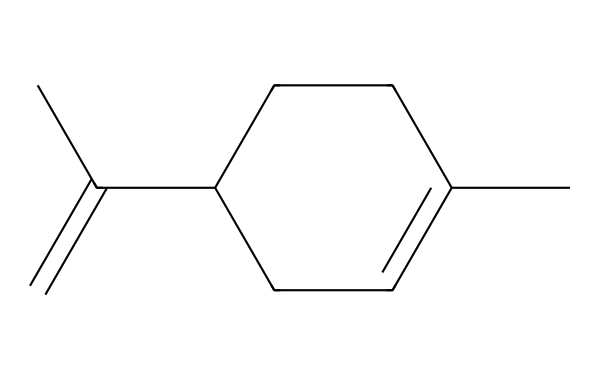What is the name of this chemical? The structure is characteristic of limonene, which is a common terpene. Its molecular structure typically includes the five-membered cyclohexene ring and two double bonds, fitting the description of limonene.
Answer: limonene How many carbon atoms are in limonene? By analyzing the SMILES representation, we count a total of 10 carbon atoms in the structure, which are denoted by the 'C' characters.
Answer: 10 How many double bonds are present in the structure? In the SMILES notation, there are two instances of '=C' indicating double bonds, confirming that there are two double bonds in the structure of limonene.
Answer: 2 Does limonene contain any functional groups? Upon examining the structure, there are no specific functional groups like alcohols or acids; it mainly contains carbon and hydrogen, typical for aliphatic compounds.
Answer: No What type of aliphatic compound is limonene categorized as? Limonene is classified as a monoterpene, which is a specific type of terpenoid that consists of two isoprene units and contains the characteristic cycloalkene structure.
Answer: monoterpene Which part of the structure contributes to the citrus scent? The distinct arrangement of the double bonds and the presence of the cyclohexene ring is what primarily gives limonene its citrus aroma.
Answer: cyclohexene ring Is limonene a saturated or unsaturated compound? The presence of double bonds in the structure indicates that limonene is unsaturated, as saturated compounds contain only single bonds.
Answer: unsaturated 